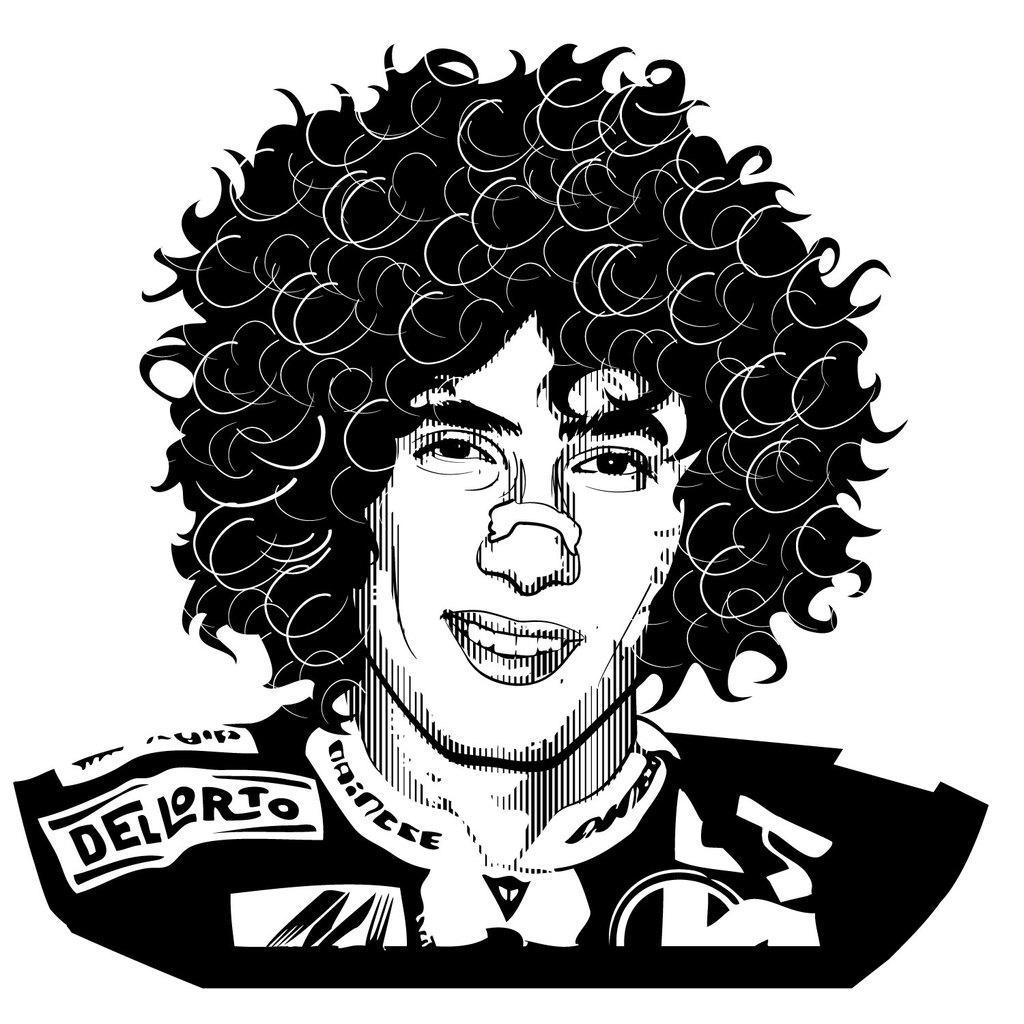Could you give a brief overview of what you see in this image? In this picture I can see black and white photo of a person. 